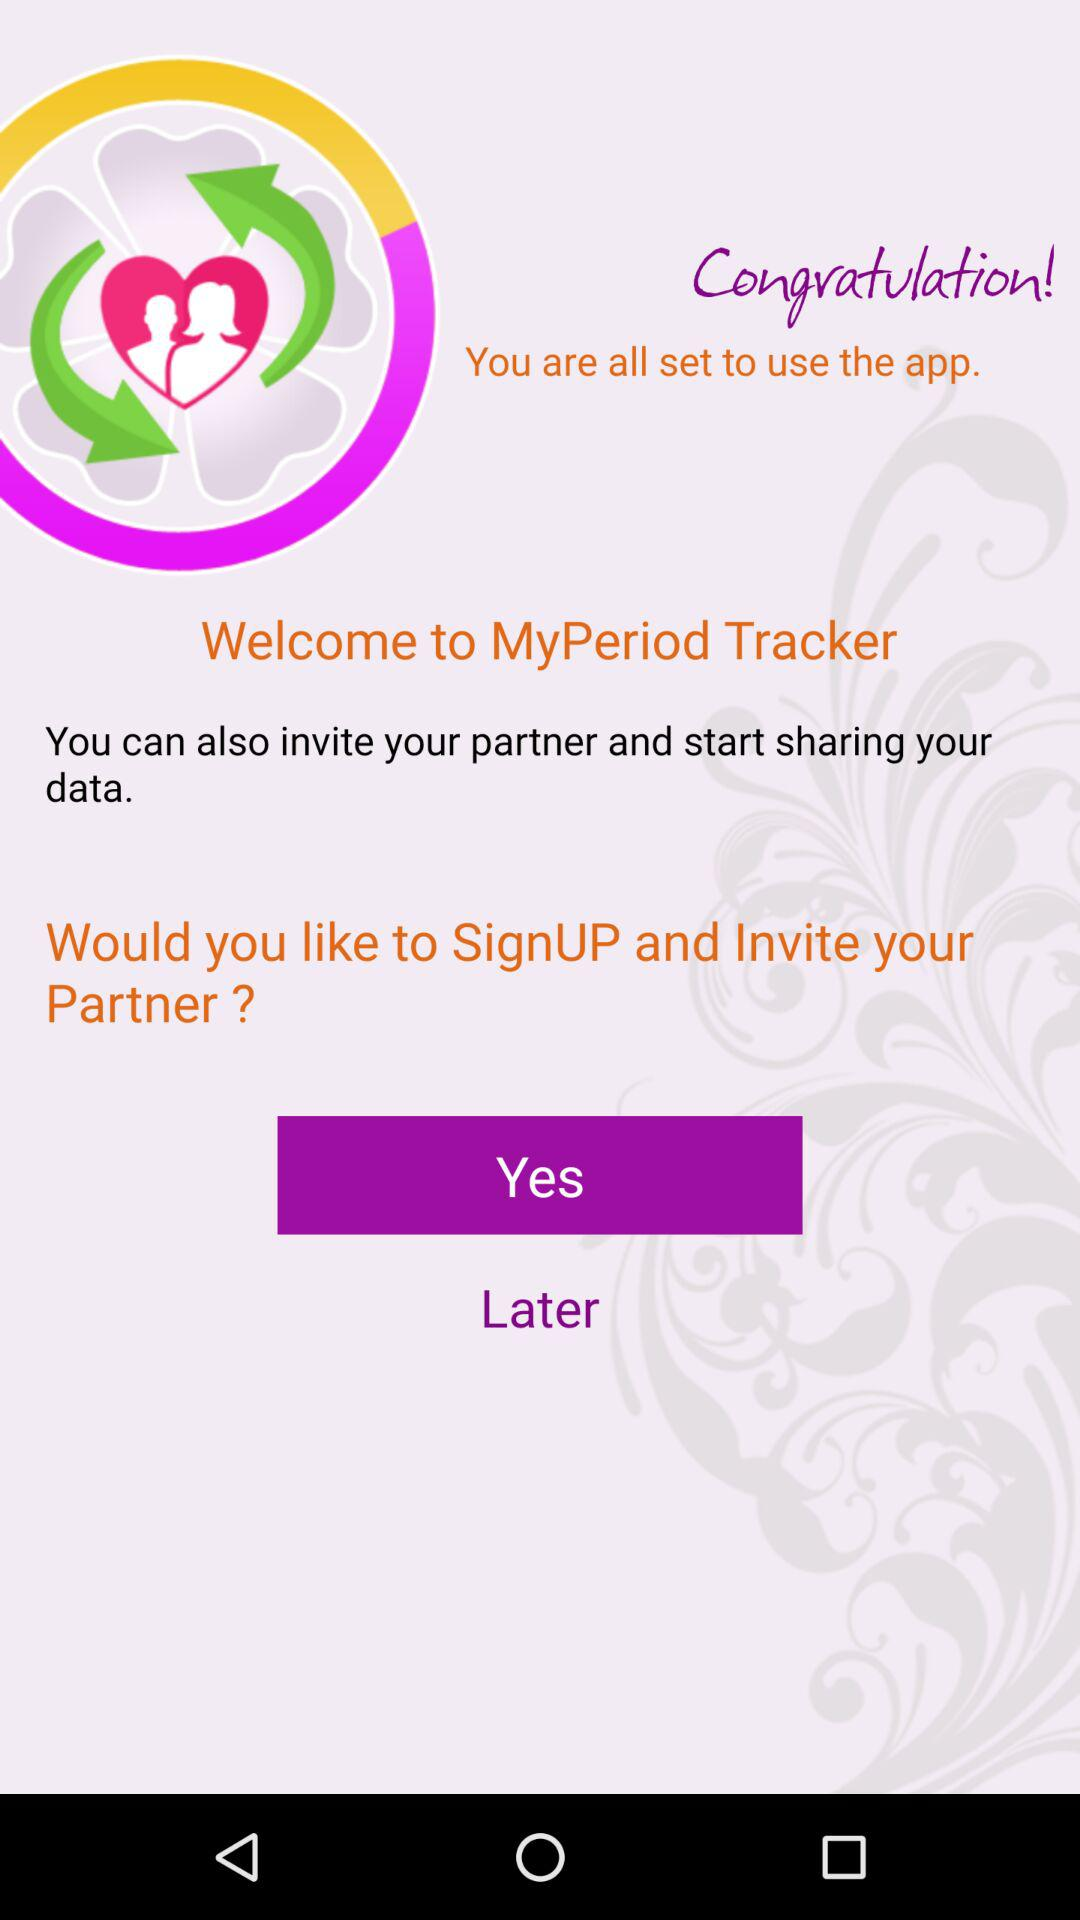Through which apps can the data be shared?
When the provided information is insufficient, respond with <no answer>. <no answer> 